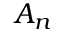<formula> <loc_0><loc_0><loc_500><loc_500>A _ { n }</formula> 